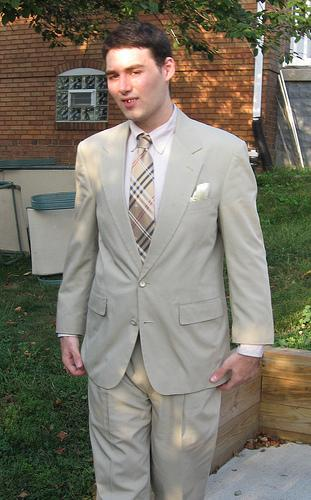Question: what material is the building made out of?
Choices:
A. Concrete.
B. Plastic.
C. Brick.
D. Wood.
Answer with the letter. Answer: C Question: what is the main color of the person's clothes?
Choices:
A. Grey.
B. Purple.
C. Blue.
D. Orange.
Answer with the letter. Answer: A Question: how many people are pictured?
Choices:
A. One.
B. Two.
C. Three.
D. Four.
Answer with the letter. Answer: A Question: what material is used for the short wall above the sidewalk?
Choices:
A. Bricks.
B. Concrete.
C. Wood.
D. Vinyl.
Answer with the letter. Answer: C Question: what color is the top part of the rain spout?
Choices:
A. Yellow.
B. Green.
C. Red.
D. White.
Answer with the letter. Answer: D 